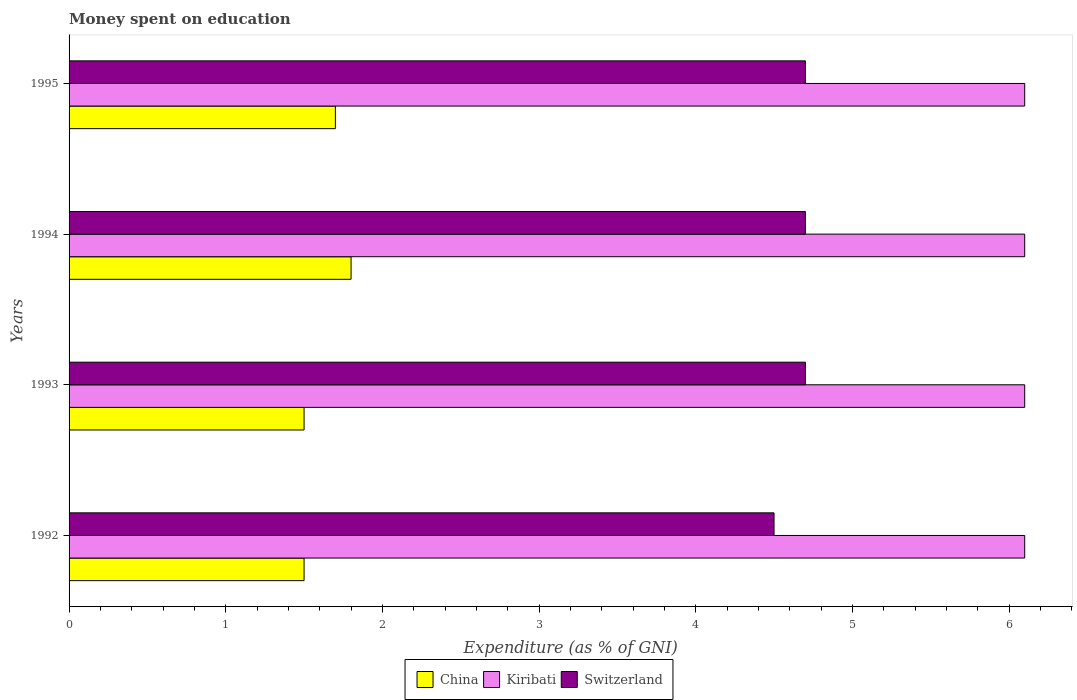How many different coloured bars are there?
Offer a very short reply. 3. How many groups of bars are there?
Offer a very short reply. 4. Are the number of bars on each tick of the Y-axis equal?
Ensure brevity in your answer.  Yes. How many bars are there on the 4th tick from the top?
Ensure brevity in your answer.  3. How many bars are there on the 3rd tick from the bottom?
Keep it short and to the point. 3. What is the label of the 3rd group of bars from the top?
Offer a terse response. 1993. In how many cases, is the number of bars for a given year not equal to the number of legend labels?
Your answer should be very brief. 0. What is the amount of money spent on education in Switzerland in 1992?
Offer a terse response. 4.5. In which year was the amount of money spent on education in Switzerland maximum?
Offer a terse response. 1993. What is the total amount of money spent on education in China in the graph?
Offer a very short reply. 6.5. What is the difference between the amount of money spent on education in Switzerland in 1994 and the amount of money spent on education in China in 1993?
Provide a succinct answer. 3.2. What is the average amount of money spent on education in Kiribati per year?
Keep it short and to the point. 6.1. In the year 1995, what is the difference between the amount of money spent on education in Switzerland and amount of money spent on education in Kiribati?
Your answer should be compact. -1.4. What is the ratio of the amount of money spent on education in China in 1992 to that in 1993?
Your answer should be very brief. 1. What does the 3rd bar from the top in 1993 represents?
Your answer should be compact. China. How many years are there in the graph?
Provide a succinct answer. 4. What is the difference between two consecutive major ticks on the X-axis?
Ensure brevity in your answer.  1. Are the values on the major ticks of X-axis written in scientific E-notation?
Provide a short and direct response. No. Does the graph contain any zero values?
Make the answer very short. No. Does the graph contain grids?
Make the answer very short. No. Where does the legend appear in the graph?
Offer a very short reply. Bottom center. How many legend labels are there?
Make the answer very short. 3. What is the title of the graph?
Your answer should be very brief. Money spent on education. Does "Sierra Leone" appear as one of the legend labels in the graph?
Offer a very short reply. No. What is the label or title of the X-axis?
Give a very brief answer. Expenditure (as % of GNI). What is the Expenditure (as % of GNI) of China in 1992?
Your answer should be very brief. 1.5. What is the Expenditure (as % of GNI) in Kiribati in 1992?
Give a very brief answer. 6.1. What is the Expenditure (as % of GNI) in Switzerland in 1992?
Give a very brief answer. 4.5. What is the Expenditure (as % of GNI) of China in 1993?
Your answer should be compact. 1.5. What is the Expenditure (as % of GNI) in Switzerland in 1993?
Ensure brevity in your answer.  4.7. What is the Expenditure (as % of GNI) in Kiribati in 1994?
Your response must be concise. 6.1. What is the Expenditure (as % of GNI) in Switzerland in 1994?
Ensure brevity in your answer.  4.7. What is the Expenditure (as % of GNI) of Switzerland in 1995?
Provide a short and direct response. 4.7. Across all years, what is the maximum Expenditure (as % of GNI) of Kiribati?
Ensure brevity in your answer.  6.1. Across all years, what is the minimum Expenditure (as % of GNI) of Switzerland?
Keep it short and to the point. 4.5. What is the total Expenditure (as % of GNI) in China in the graph?
Your response must be concise. 6.5. What is the total Expenditure (as % of GNI) of Kiribati in the graph?
Provide a short and direct response. 24.4. What is the total Expenditure (as % of GNI) of Switzerland in the graph?
Your response must be concise. 18.6. What is the difference between the Expenditure (as % of GNI) of China in 1992 and that in 1994?
Your response must be concise. -0.3. What is the difference between the Expenditure (as % of GNI) in Kiribati in 1992 and that in 1994?
Give a very brief answer. 0. What is the difference between the Expenditure (as % of GNI) in Switzerland in 1992 and that in 1994?
Provide a succinct answer. -0.2. What is the difference between the Expenditure (as % of GNI) of Switzerland in 1992 and that in 1995?
Offer a very short reply. -0.2. What is the difference between the Expenditure (as % of GNI) in Kiribati in 1993 and that in 1994?
Offer a very short reply. 0. What is the difference between the Expenditure (as % of GNI) in Switzerland in 1993 and that in 1994?
Offer a very short reply. 0. What is the difference between the Expenditure (as % of GNI) of China in 1993 and that in 1995?
Provide a succinct answer. -0.2. What is the difference between the Expenditure (as % of GNI) of China in 1994 and that in 1995?
Your answer should be compact. 0.1. What is the difference between the Expenditure (as % of GNI) in Kiribati in 1992 and the Expenditure (as % of GNI) in Switzerland in 1993?
Your response must be concise. 1.4. What is the difference between the Expenditure (as % of GNI) of China in 1992 and the Expenditure (as % of GNI) of Kiribati in 1994?
Ensure brevity in your answer.  -4.6. What is the difference between the Expenditure (as % of GNI) in China in 1992 and the Expenditure (as % of GNI) in Switzerland in 1994?
Your response must be concise. -3.2. What is the difference between the Expenditure (as % of GNI) in Kiribati in 1992 and the Expenditure (as % of GNI) in Switzerland in 1994?
Your response must be concise. 1.4. What is the difference between the Expenditure (as % of GNI) in China in 1992 and the Expenditure (as % of GNI) in Switzerland in 1995?
Your answer should be compact. -3.2. What is the difference between the Expenditure (as % of GNI) in Kiribati in 1992 and the Expenditure (as % of GNI) in Switzerland in 1995?
Your answer should be very brief. 1.4. What is the difference between the Expenditure (as % of GNI) in China in 1993 and the Expenditure (as % of GNI) in Kiribati in 1994?
Your response must be concise. -4.6. What is the difference between the Expenditure (as % of GNI) in Kiribati in 1993 and the Expenditure (as % of GNI) in Switzerland in 1994?
Your answer should be compact. 1.4. What is the difference between the Expenditure (as % of GNI) of China in 1993 and the Expenditure (as % of GNI) of Kiribati in 1995?
Keep it short and to the point. -4.6. What is the difference between the Expenditure (as % of GNI) in China in 1993 and the Expenditure (as % of GNI) in Switzerland in 1995?
Your answer should be very brief. -3.2. What is the difference between the Expenditure (as % of GNI) of Kiribati in 1993 and the Expenditure (as % of GNI) of Switzerland in 1995?
Give a very brief answer. 1.4. What is the difference between the Expenditure (as % of GNI) in China in 1994 and the Expenditure (as % of GNI) in Kiribati in 1995?
Ensure brevity in your answer.  -4.3. What is the difference between the Expenditure (as % of GNI) of China in 1994 and the Expenditure (as % of GNI) of Switzerland in 1995?
Provide a succinct answer. -2.9. What is the difference between the Expenditure (as % of GNI) of Kiribati in 1994 and the Expenditure (as % of GNI) of Switzerland in 1995?
Make the answer very short. 1.4. What is the average Expenditure (as % of GNI) in China per year?
Ensure brevity in your answer.  1.62. What is the average Expenditure (as % of GNI) of Kiribati per year?
Keep it short and to the point. 6.1. What is the average Expenditure (as % of GNI) in Switzerland per year?
Make the answer very short. 4.65. In the year 1992, what is the difference between the Expenditure (as % of GNI) of Kiribati and Expenditure (as % of GNI) of Switzerland?
Your answer should be very brief. 1.6. In the year 1993, what is the difference between the Expenditure (as % of GNI) in China and Expenditure (as % of GNI) in Switzerland?
Give a very brief answer. -3.2. In the year 1993, what is the difference between the Expenditure (as % of GNI) of Kiribati and Expenditure (as % of GNI) of Switzerland?
Provide a short and direct response. 1.4. In the year 1994, what is the difference between the Expenditure (as % of GNI) of China and Expenditure (as % of GNI) of Kiribati?
Offer a very short reply. -4.3. In the year 1995, what is the difference between the Expenditure (as % of GNI) of China and Expenditure (as % of GNI) of Kiribati?
Make the answer very short. -4.4. In the year 1995, what is the difference between the Expenditure (as % of GNI) in China and Expenditure (as % of GNI) in Switzerland?
Make the answer very short. -3. What is the ratio of the Expenditure (as % of GNI) of China in 1992 to that in 1993?
Ensure brevity in your answer.  1. What is the ratio of the Expenditure (as % of GNI) of Switzerland in 1992 to that in 1993?
Give a very brief answer. 0.96. What is the ratio of the Expenditure (as % of GNI) of Switzerland in 1992 to that in 1994?
Ensure brevity in your answer.  0.96. What is the ratio of the Expenditure (as % of GNI) of China in 1992 to that in 1995?
Your answer should be very brief. 0.88. What is the ratio of the Expenditure (as % of GNI) in Kiribati in 1992 to that in 1995?
Make the answer very short. 1. What is the ratio of the Expenditure (as % of GNI) of Switzerland in 1992 to that in 1995?
Make the answer very short. 0.96. What is the ratio of the Expenditure (as % of GNI) of Kiribati in 1993 to that in 1994?
Give a very brief answer. 1. What is the ratio of the Expenditure (as % of GNI) in China in 1993 to that in 1995?
Your answer should be compact. 0.88. What is the ratio of the Expenditure (as % of GNI) of Kiribati in 1993 to that in 1995?
Offer a very short reply. 1. What is the ratio of the Expenditure (as % of GNI) of China in 1994 to that in 1995?
Your answer should be compact. 1.06. What is the ratio of the Expenditure (as % of GNI) of Switzerland in 1994 to that in 1995?
Make the answer very short. 1. What is the difference between the highest and the second highest Expenditure (as % of GNI) of Switzerland?
Give a very brief answer. 0. What is the difference between the highest and the lowest Expenditure (as % of GNI) in China?
Your answer should be very brief. 0.3. What is the difference between the highest and the lowest Expenditure (as % of GNI) in Switzerland?
Provide a succinct answer. 0.2. 